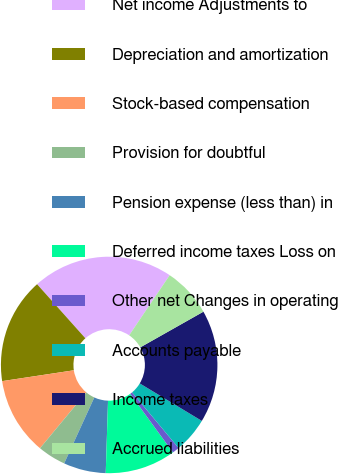<chart> <loc_0><loc_0><loc_500><loc_500><pie_chart><fcel>Net income Adjustments to<fcel>Depreciation and amortization<fcel>Stock-based compensation<fcel>Provision for doubtful<fcel>Pension expense (less than) in<fcel>Deferred income taxes Loss on<fcel>Other net Changes in operating<fcel>Accounts payable<fcel>Income taxes<fcel>Accrued liabilities<nl><fcel>21.05%<fcel>15.79%<fcel>11.58%<fcel>4.21%<fcel>6.32%<fcel>10.53%<fcel>1.06%<fcel>5.27%<fcel>16.84%<fcel>7.37%<nl></chart> 